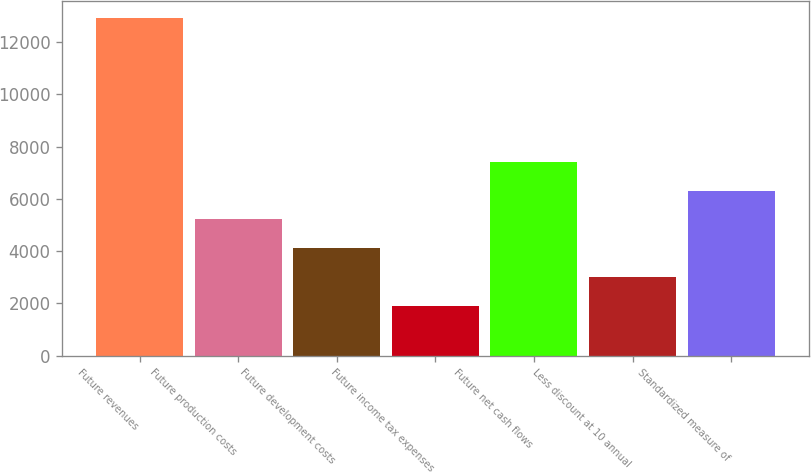Convert chart. <chart><loc_0><loc_0><loc_500><loc_500><bar_chart><fcel>Future revenues<fcel>Future production costs<fcel>Future development costs<fcel>Future income tax expenses<fcel>Future net cash flows<fcel>Less discount at 10 annual<fcel>Standardized measure of<nl><fcel>12917<fcel>5211.4<fcel>4110.6<fcel>1909<fcel>7413<fcel>3009.8<fcel>6312.2<nl></chart> 